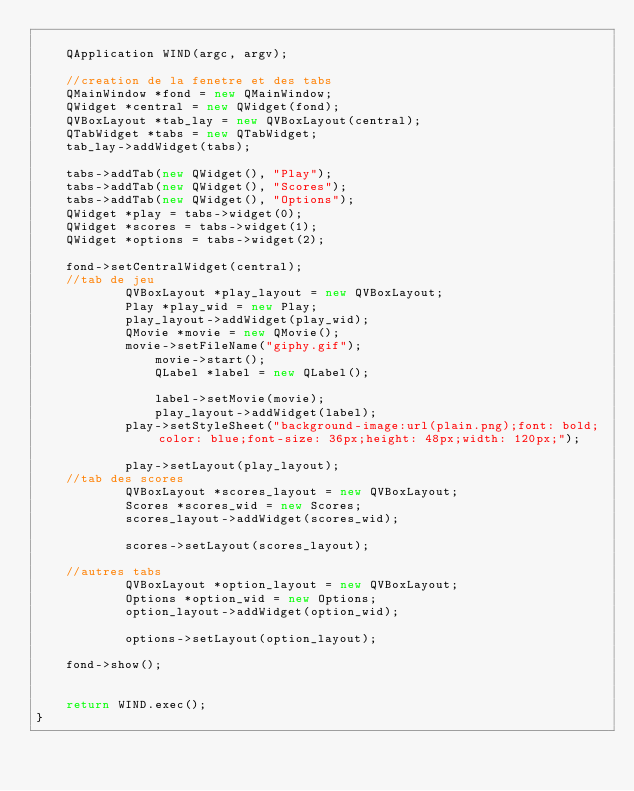Convert code to text. <code><loc_0><loc_0><loc_500><loc_500><_C++_>	
	QApplication WIND(argc, argv);

	//creation de la fenetre et des tabs
	QMainWindow *fond = new QMainWindow;
	QWidget *central = new QWidget(fond);
	QVBoxLayout *tab_lay = new QVBoxLayout(central);
	QTabWidget *tabs = new QTabWidget;
	tab_lay->addWidget(tabs);
	
	tabs->addTab(new QWidget(), "Play");
	tabs->addTab(new QWidget(), "Scores");
	tabs->addTab(new QWidget(), "Options");
	QWidget *play = tabs->widget(0);
	QWidget *scores = tabs->widget(1);
	QWidget *options = tabs->widget(2);

	fond->setCentralWidget(central);
	//tab de jeu
			QVBoxLayout *play_layout = new QVBoxLayout;
			Play *play_wid = new Play;
			play_layout->addWidget(play_wid);
			QMovie *movie = new QMovie();
			movie->setFileName("giphy.gif");
				movie->start();
				QLabel *label = new QLabel();
				
				label->setMovie(movie);
				play_layout->addWidget(label);
			play->setStyleSheet("background-image:url(plain.png);font: bold; color: blue;font-size: 36px;height: 48px;width: 120px;");
			
			play->setLayout(play_layout);
	//tab des scores
			QVBoxLayout *scores_layout = new QVBoxLayout;
			Scores *scores_wid = new Scores;
			scores_layout->addWidget(scores_wid);

			scores->setLayout(scores_layout);

	//autres tabs
			QVBoxLayout *option_layout = new QVBoxLayout;
			Options *option_wid = new Options;
			option_layout->addWidget(option_wid);

			options->setLayout(option_layout);
			
	fond->show();


	return WIND.exec();
}</code> 